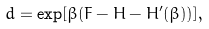Convert formula to latex. <formula><loc_0><loc_0><loc_500><loc_500>d = \exp [ \beta ( F - H - H ^ { \prime } ( \beta ) ) ] ,</formula> 